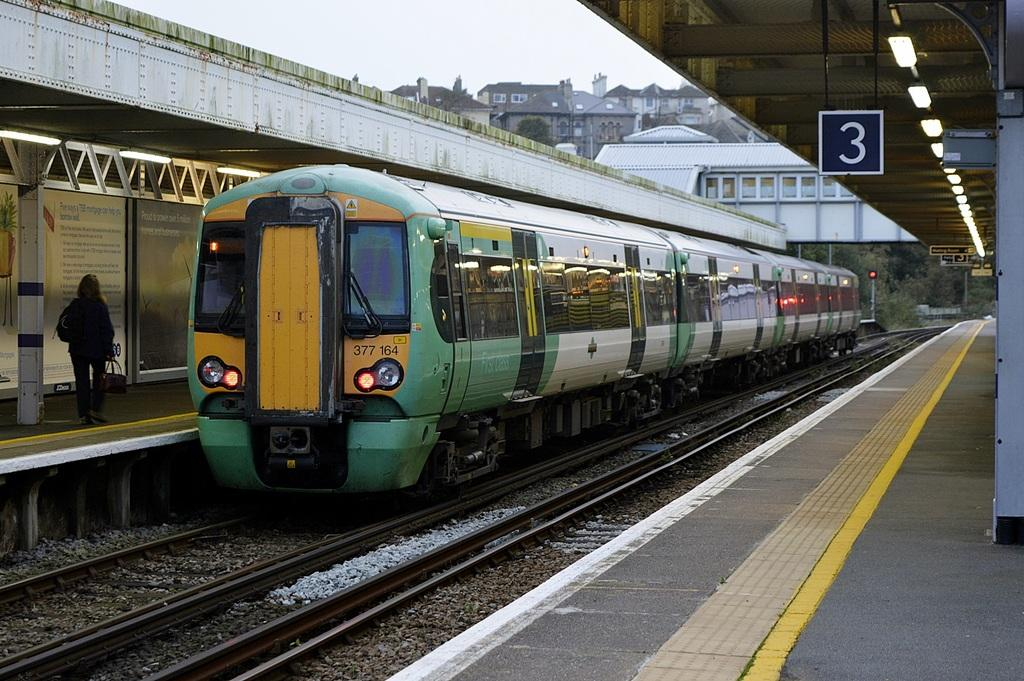<image>
Share a concise interpretation of the image provided. A train coming up to the number 3 line, a passenger is walking nearby. 